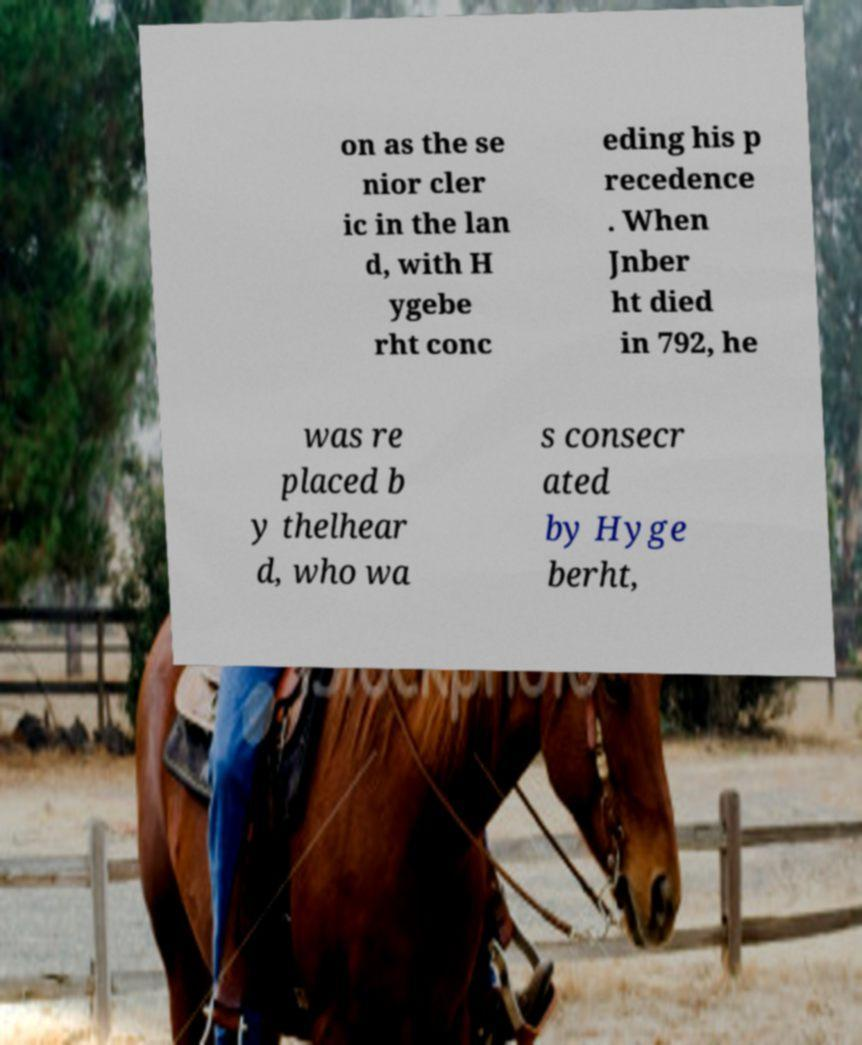Please read and relay the text visible in this image. What does it say? on as the se nior cler ic in the lan d, with H ygebe rht conc eding his p recedence . When Jnber ht died in 792, he was re placed b y thelhear d, who wa s consecr ated by Hyge berht, 